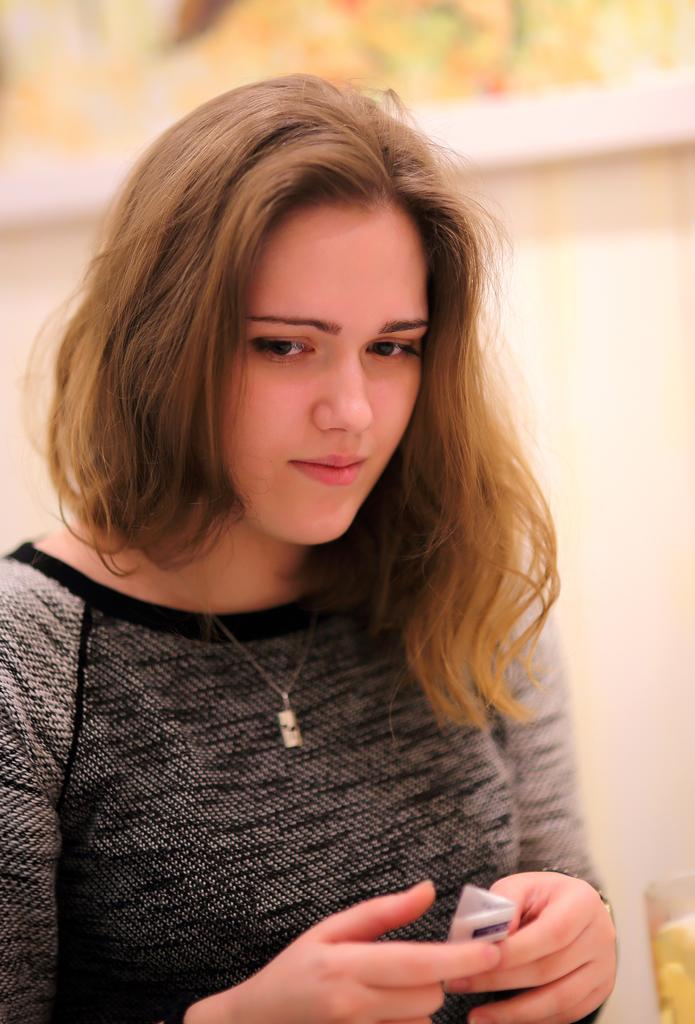What is the main subject of the image? There is a person in the image. What is the person holding in the image? The person is holding a paper. Can you describe any other objects in the image? There is an object that looks like a glass in the image. What is the condition of the background in the image? The background of the image is blurred. What type of girl can be seen turning the tank in the image? There is no girl or tank present in the image. 